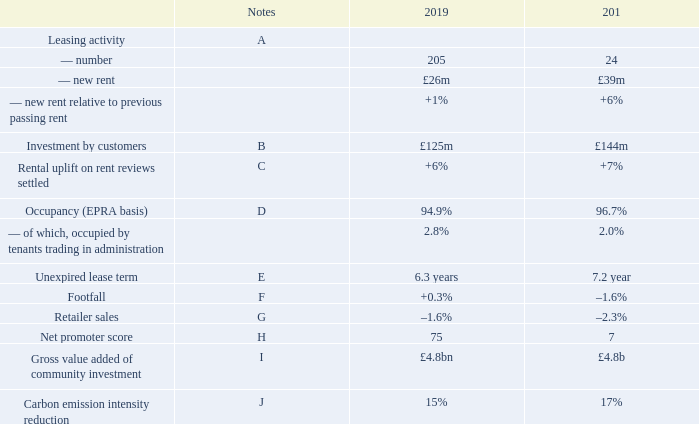Operational performance
A Leasing activity
We agreed 205 long-term leases in 2019, amounting to £26 million annual rent, at an average of 1 per cent above previous passing rent (like-for-like units) and in line with valuers’ assumptions. On a net effective basis (net of rent frees and incentives), rents were also 1 per cent ahead of previous rents. The upside from these new lettings added to like-for-like net rental income but was lower in magnitude than the negative impacts from administrations and CVAs and increased vacancy (see financial review on pages 30 to 37).
Our customers continue to focus on increasing their space in prime, high footfall retail and leisure destinations. Significant activity in 2019 included:
—pureplay online brands starting to open stores to increase their physical presence. Morphe, the digital native cosmetics brand, opened three of its six UK stores at intu Victoria Centre, intu Eldon Square and Manchester Arndale, and AliExpress, the consumer platform of Alibaba, opened its first store in Europe at intu Xanadú
—Harrods taking its first shopping centre store, launching a new beauty concept, H Beauty, at intu Lakeside
—a new flagship store for Zara at St David’s, Cardiff, where it is moving into the centre from the high street. This follows the recent upsizing of stores at intu Trafford Centre and intu Lakeside
—leisure brands increasing their space with Puttshack to open its fourth venue at intu Watford, following its successful opening at intu Lakeside. Namco is expanding its range of attractions at intu Metrocentre with Clip ‘n Climb and the first Angry Birds Adventure Golf in the UK and Rock Up is taking space at intu Lakeside
—international fashion brands continuing to expand in the UK with Spanish brand Mango due to open at intu Watford a
B Investment by customers
In the year, 256 units opened or refitted in our centres (2018: 262 stores), representing around 8 per cent of our 3,300 units. Our customers have invested around £125 million in these stores, which we believe is a significant demonstration of their long-term commitment to our centres.
C Rent reviews
We settled 159 rent reviews in 2019 for new rents totalling £45 million, an average uplift of 6 per cent on the previous rents.
D Occupancy
Occupancy was 94.9 per cent, in line with June 2019 (95.1 per cent), but a reduction against 31 December 2018 (96.7 per cent), impacted by units closed in the first half of 2019 from tenants who went into administration or through a CVA process in 2018. This had a 3.7 per cent negative impact on like-for-like net rental income in 2019 from both rents foregone and increased void costs.
E Weighted average unexpired lease term
The weighted average unexpired lease term was 6.3 years (31 December 2018: 7.2 years) illustrating the longevity of our income streams. The reduction against the prior year was primarily due to new lease terms on department stores that have been through a CVA or administration process.
F Footfall
Footfall in our centres increased by 0.3 per cent in the year. UK footfall was flat, significantly outperforming the Springboard footfall monitor for shopping centres which was down on average by 2.5 per cent. We believe this highlights the continued attraction of our compelling destinations against the wider market. In Spain, footfall was up by 3.5 per cent.
G Retailer sales
Estimated retailer sales in our UK centres, which totalled £5.2 billion in 2019, were down 1.6 per cent, impacted by some larger space users who have had difficulties and been through CVAs and those brands who operate successful multichannel models where in-store sales figures take no account of the benefit of the store to online sales. This compares favourably to the British Retail Consortium (BRC), where non-food retailer sales in-store were down 3.1 per cent on average in 2019.
The ratio of rents to estimated sales for standard units remained stable in 2019 at 12.0 per cent. This does not take into account the benefit to the retailer of their multichannel business, such as click and collect.
H Net promoter score
Our net promoter score, a measure of visitor satisfaction, ran consistently high throughout 2019 averaging 75, an increase of 2 over 2018. Visitor satisfaction is paramount to a shopper’s likelihood to visit, which in turn drives footfall and extended dwell time.
I Gross value of community investment
Gross value added, the measure of the economic contribution of intu to the local communities in the UK, remained stable in the year at £4.8 billion.
J Carbon emission intensity reduction
Annual reduction in carbon emission intensity has reduced in 2019. This is due to our continued focus on energy efficiency to reduce our overall energy demand each year, supported by the ongoing greening of the electricity grid as we become less reliant on coal and increase our renewable generation.
Our 2020 target was to reduce carbon emission intensity by 50 per cent, against a 2010 baseline. We reached this target three years ahead of plan and at the end of 2019, our reduction total was 69 per cent.
What are the components of leasing activity? Number, new rent, new rent relative to previous passing rent. What is the amount of investment in the stores made by customers in 2019? £125 million. What is the total number of units the Company has? 3,300 units. What is the percentage change in the number of leasing activity from 2018 to 2019?
Answer scale should be: percent. (205-24)/24
Answer: 754.17. What is the percentage change in the investment by customers from 2018 to 2019?
Answer scale should be: percent. (125-144)/144
Answer: -13.19. What is the percentage change in the number of opened or refitted unites in the centres from 2018 to 2019?
Answer scale should be: percent. (256-262)/262
Answer: -2.29. 